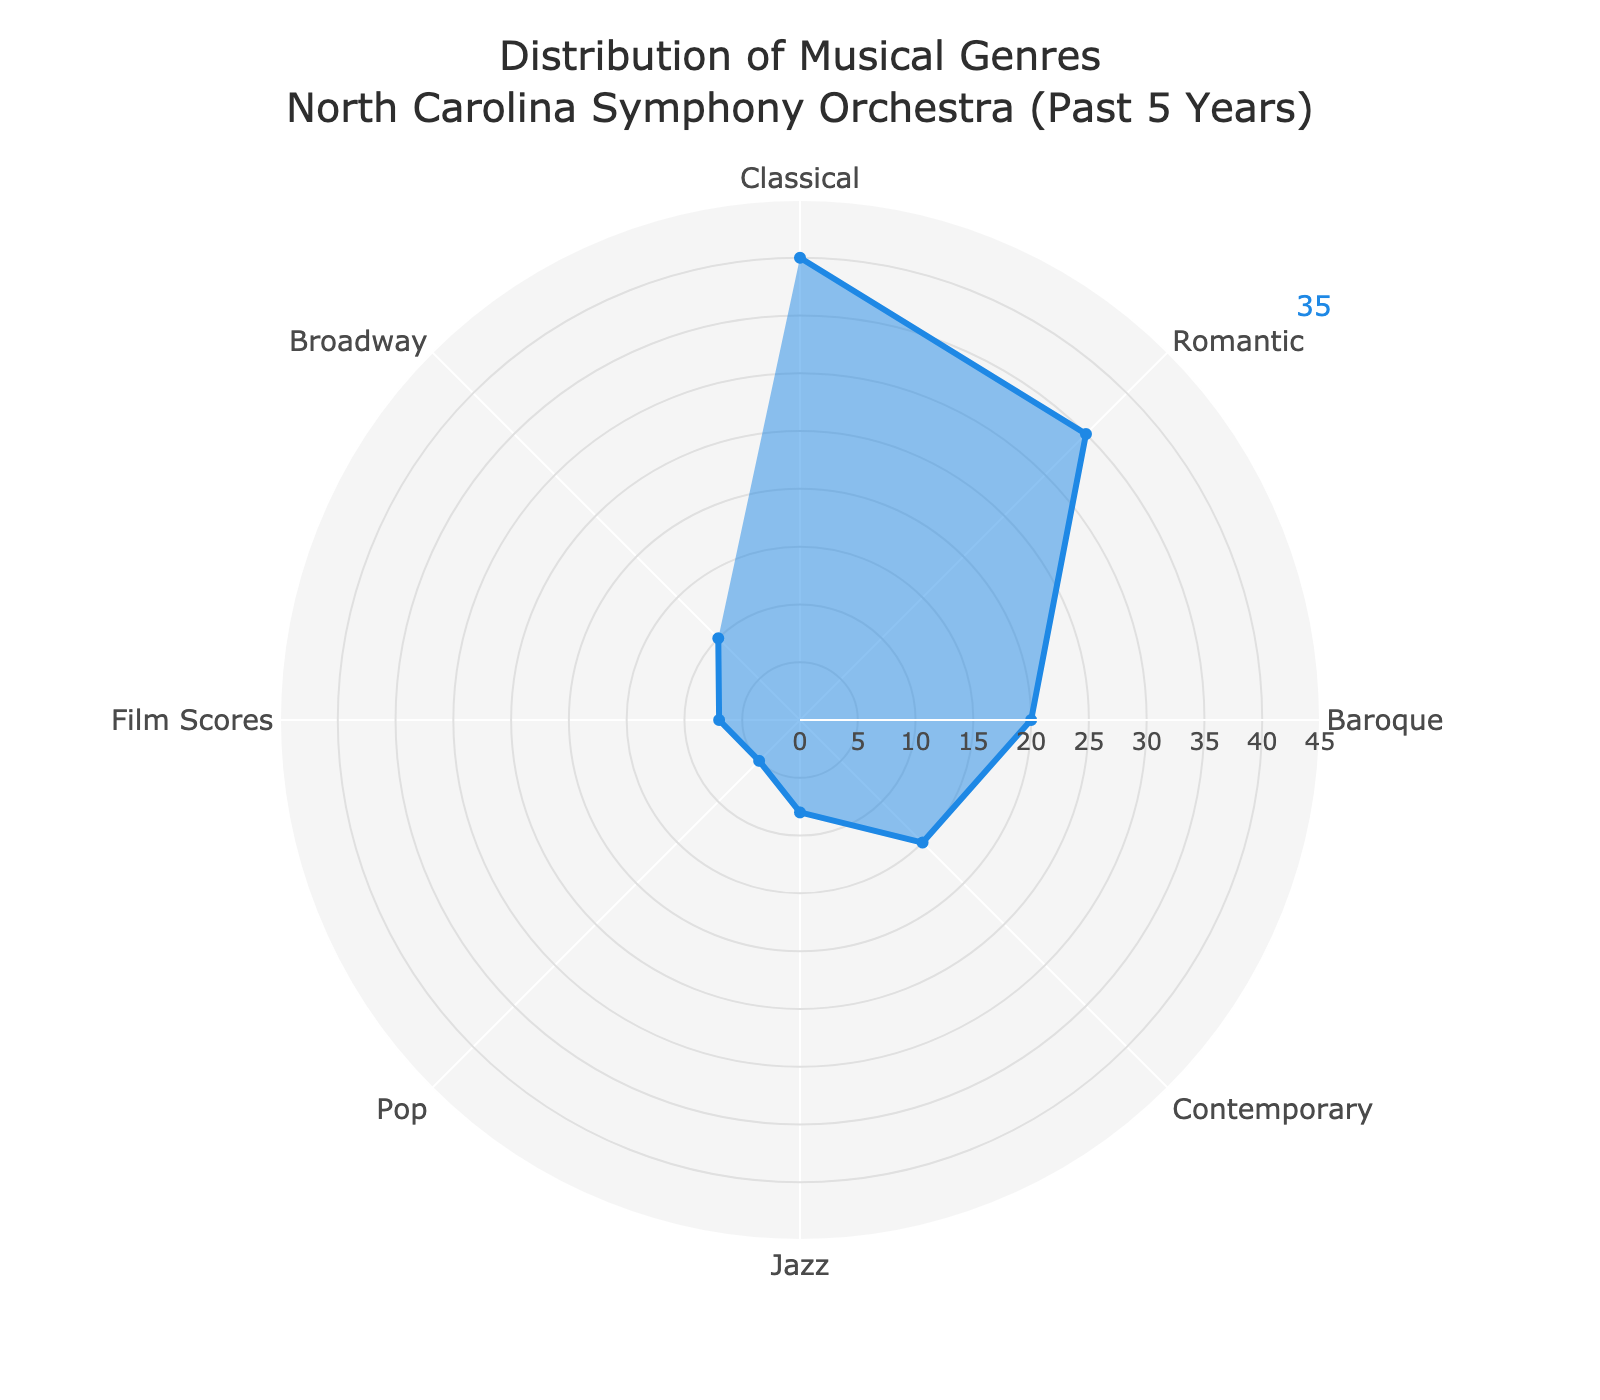What's the total number of performances over the past five years? To find the total, sum the counts of performances for all genres: 40 (Classical) + 35 (Romantic) + 20 (Baroque) + 15 (Contemporary) + 8 (Jazz) + 5 (Pop) + 7 (Film Scores) + 10 (Broadway) = 140
Answer: 140 Which genre has the highest number of performances? The genre with the highest number of performances can be determined by identifying the highest value in the 'Count' series in the figure. Classical has the highest count at 40.
Answer: Classical How many more performances of Classical were there compared to Contemporary? Subtract the number of Contemporary performances from the number of Classical performances. 40 (Classical) - 15 (Contemporary) = 25
Answer: 25 What's the average number of performances for the genres listed? Calculate the average by summing all the counts and then dividing by the number of genres: (40 + 35 + 20 + 15 + 8 + 5 + 7 + 10) / 8 = 140 / 8 = 17.5
Answer: 17.5 Which genres have counts above the average number of performances? First, determine the average number (17.5). Then, list genres with counts above this number: Classical (40), Romantic (35), Baroque (20)
Answer: Classical, Romantic, Baroque Are there more Jazz or Broadway performances? Compare the counts for Jazz and Broadway. Jazz has 8 performances, and Broadway has 10. Since 10 > 8, Broadway has more performances.
Answer: Broadway What's the difference in the number of performances between Film Scores and Pop? Subtract the count of Pop performances from the count of Film Scores performances. 7 (Film Scores) - 5 (Pop) = 2
Answer: 2 Which genre has the fewest performances? Identify the genre with the lowest count in the figure. Pop has the fewest performances with 5.
Answer: Pop How many genres have more than 10 performances? Count the genres with over 10 performances. Classical (40), Romantic (35), Baroque (20), and Broadway (10) have more than 10 performances. There are 4 such genres.
Answer: 4 